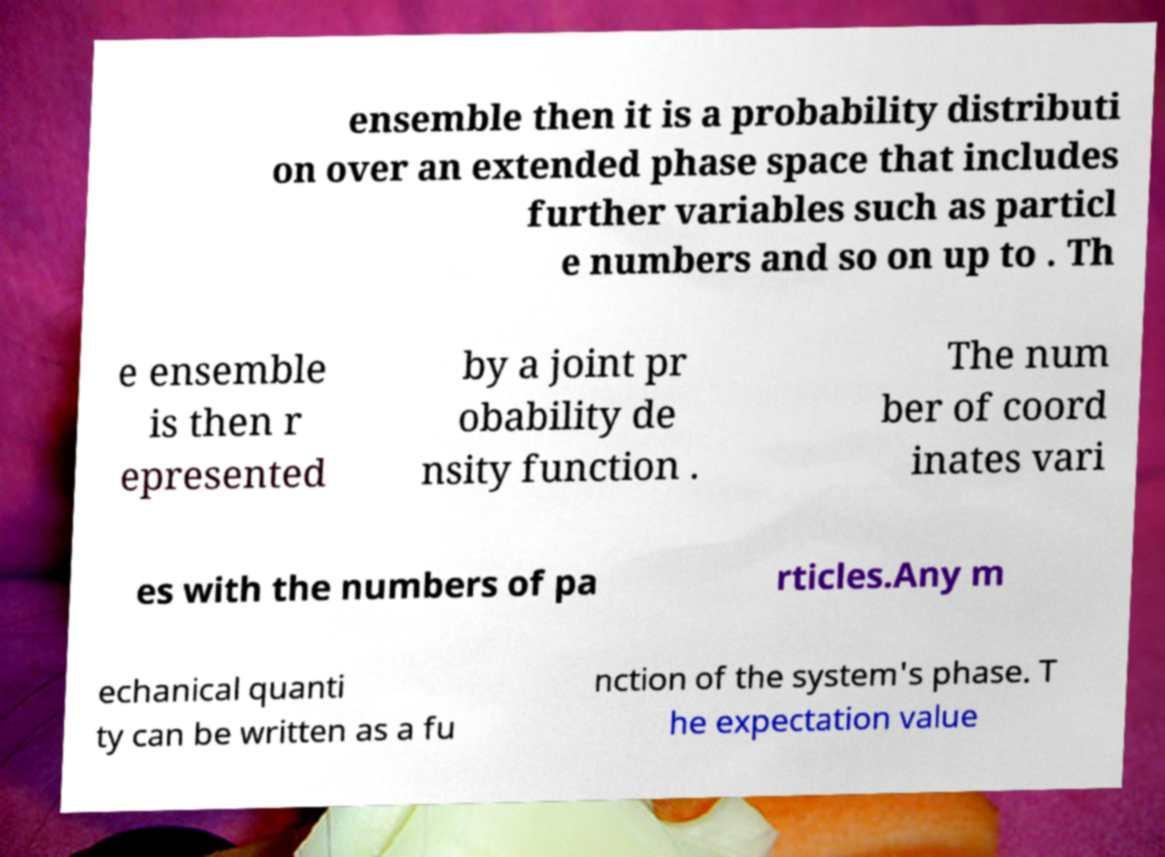What messages or text are displayed in this image? I need them in a readable, typed format. ensemble then it is a probability distributi on over an extended phase space that includes further variables such as particl e numbers and so on up to . Th e ensemble is then r epresented by a joint pr obability de nsity function . The num ber of coord inates vari es with the numbers of pa rticles.Any m echanical quanti ty can be written as a fu nction of the system's phase. T he expectation value 